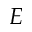<formula> <loc_0><loc_0><loc_500><loc_500>E</formula> 